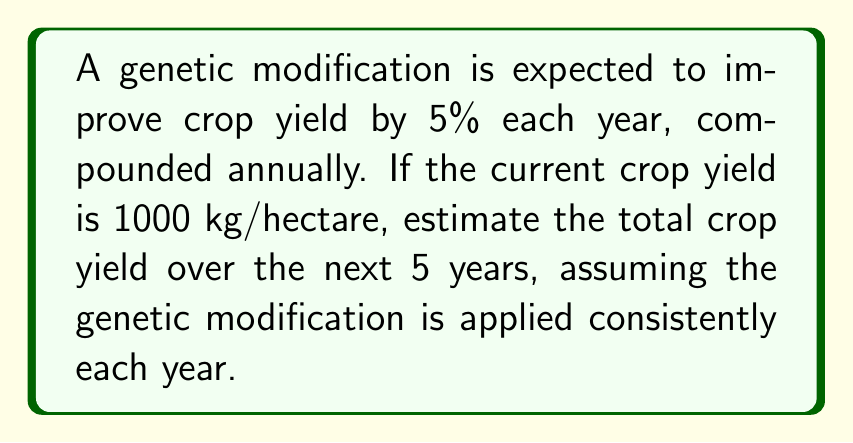Can you solve this math problem? To solve this problem, we need to use the formula for the sum of a geometric series:

$$S_n = a\frac{1-r^n}{1-r}$$

Where:
$S_n$ is the sum of the series
$a$ is the first term
$r$ is the common ratio
$n$ is the number of terms

Let's break this down step-by-step:

1) The yield increases by 5% each year, so the common ratio is $r = 1.05$

2) The initial yield is 1000 kg/hectare, so $a = 1000$

3) We want to calculate the yield for 5 years, so $n = 5$

4) Let's substitute these values into our formula:

   $$S_5 = 1000\frac{1-1.05^5}{1-1.05}$$

5) Now let's calculate $1.05^5$:
   
   $$1.05^5 = 1.2762815625$$

6) Substituting this back in:

   $$S_5 = 1000\frac{1-1.2762815625}{1-1.05} = 1000\frac{-0.2762815625}{-0.05}$$

7) Simplifying:

   $$S_5 = 1000 \times 5.52563125 = 5525.63125$$

Therefore, the total crop yield over the 5 years is approximately 5525.63 kg/hectare.
Answer: 5525.63 kg/hectare 